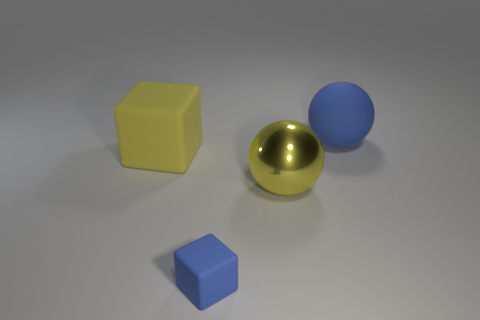There is a blue thing that is the same shape as the big yellow rubber thing; what is its size?
Provide a short and direct response. Small. What is the small blue cube made of?
Ensure brevity in your answer.  Rubber. There is a large sphere that is behind the yellow thing right of the blue object left of the large blue object; what is it made of?
Your answer should be very brief. Rubber. Is there anything else that is the same shape as the small thing?
Offer a terse response. Yes. The big matte thing that is the same shape as the small blue matte object is what color?
Your response must be concise. Yellow. Does the large sphere that is behind the large yellow metal thing have the same color as the large ball that is in front of the large blue rubber ball?
Your response must be concise. No. Are there more big yellow metallic objects that are on the left side of the tiny blue thing than tiny blue matte blocks?
Offer a terse response. No. What number of other objects are there of the same size as the yellow shiny sphere?
Your answer should be compact. 2. How many big things are both behind the yellow metallic sphere and to the right of the blue block?
Provide a succinct answer. 1. Does the large sphere that is on the left side of the big blue sphere have the same material as the large blue sphere?
Offer a very short reply. No. 